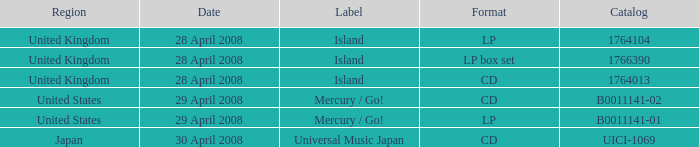What label is attributed to the uici-1069 catalog? Universal Music Japan. 